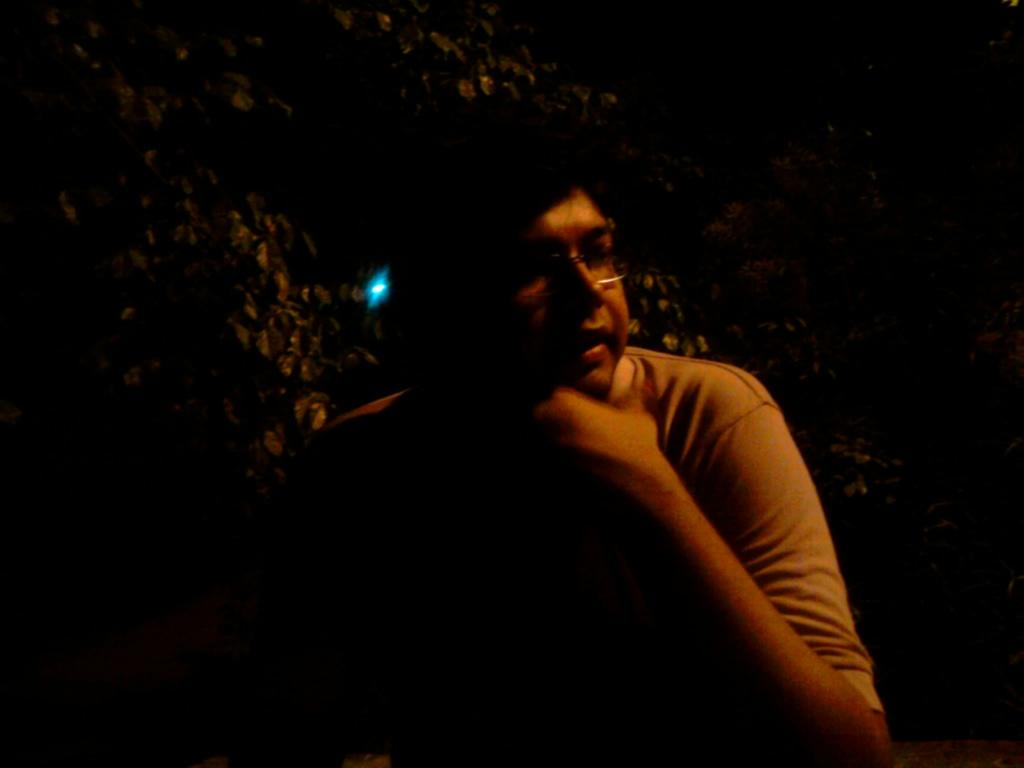Who is present in the image? There is a man in the image. What accessory is the man wearing? The man is wearing glasses. What color light can be seen in the image? There is a blue color light in the image. What type of vegetation is visible in the background of the image? Leaves are visible in the background of the image. How would you describe the lighting conditions in the image? The image appears to be in a dark setting. What type of cheese is being used as a caption in the image? There is no cheese or caption present in the image. 